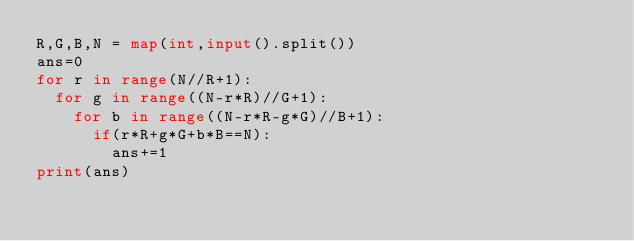Convert code to text. <code><loc_0><loc_0><loc_500><loc_500><_Python_>R,G,B,N = map(int,input().split())
ans=0
for r in range(N//R+1):
  for g in range((N-r*R)//G+1):
    for b in range((N-r*R-g*G)//B+1):
      if(r*R+g*G+b*B==N):
	      ans+=1
print(ans)</code> 